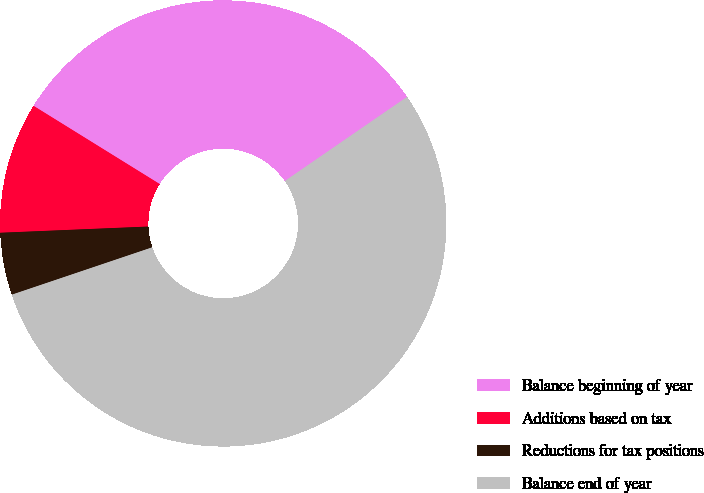<chart> <loc_0><loc_0><loc_500><loc_500><pie_chart><fcel>Balance beginning of year<fcel>Additions based on tax<fcel>Reductions for tax positions<fcel>Balance end of year<nl><fcel>31.58%<fcel>9.5%<fcel>4.51%<fcel>54.42%<nl></chart> 